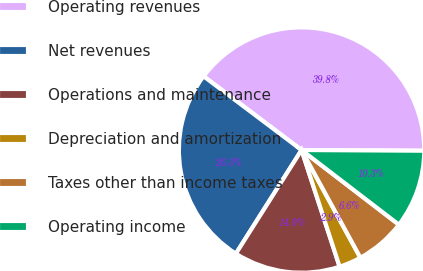<chart> <loc_0><loc_0><loc_500><loc_500><pie_chart><fcel>Operating revenues<fcel>Net revenues<fcel>Operations and maintenance<fcel>Depreciation and amortization<fcel>Taxes other than income taxes<fcel>Operating income<nl><fcel>39.82%<fcel>26.28%<fcel>14.01%<fcel>2.94%<fcel>6.63%<fcel>10.32%<nl></chart> 